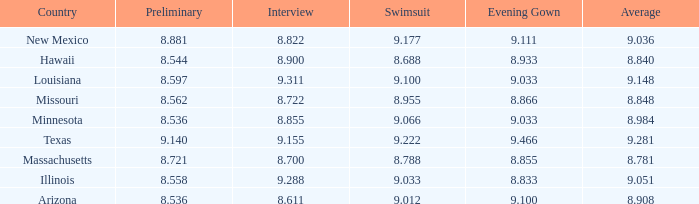What was the swimsuit score for the country with the average score of 8.848? 8.955. 